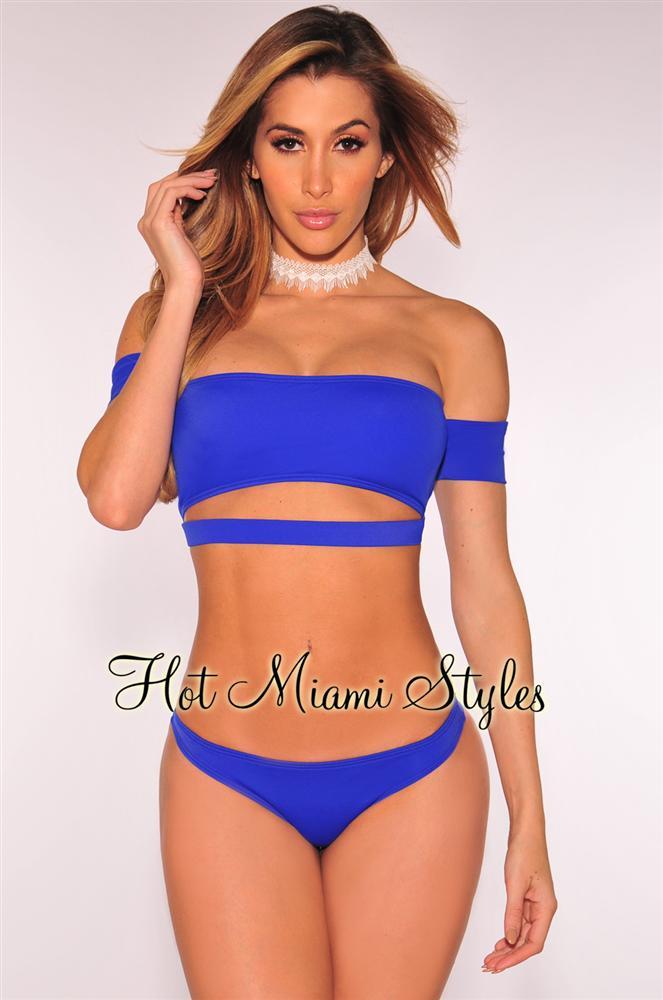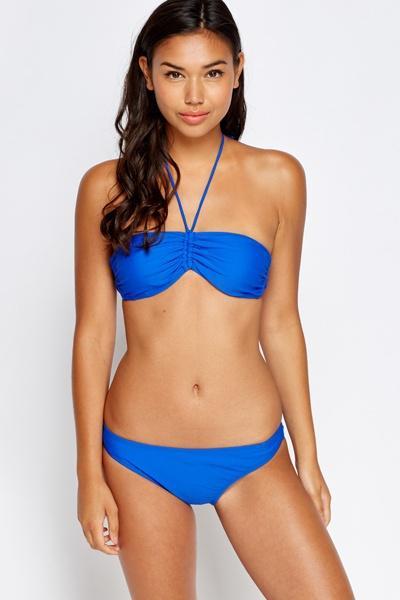The first image is the image on the left, the second image is the image on the right. Assess this claim about the two images: "In one image, a woman is wearing a necklace.". Correct or not? Answer yes or no. Yes. The first image is the image on the left, the second image is the image on the right. Examine the images to the left and right. Is the description "models are wearing high wasted bikini bottoms" accurate? Answer yes or no. No. 